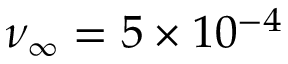Convert formula to latex. <formula><loc_0><loc_0><loc_500><loc_500>\nu _ { \infty } = 5 \times { 1 0 ^ { - 4 } }</formula> 